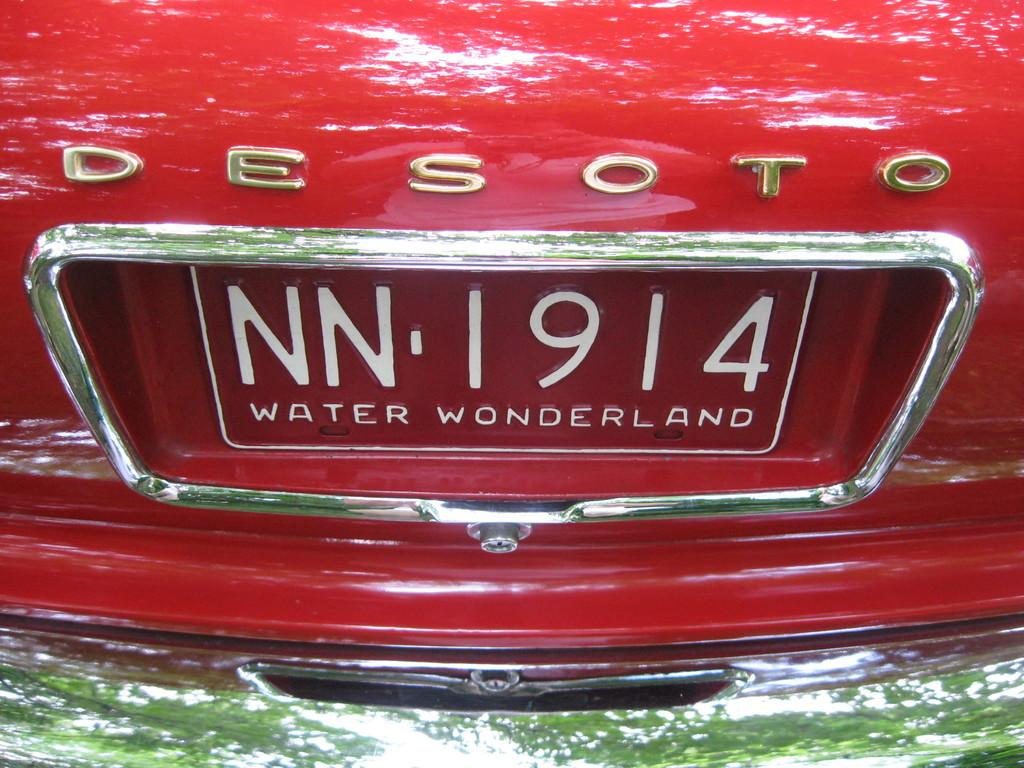What can be seen on the car in the image? There is a car number plate in the image. What else is present in the image besides the car number plate? There is a logo in the image. How many kittens can be seen playing with the pot in the image? There are no kittens or pots present in the image. What is the taste of the logo in the image? The logo is not something that can be tasted, as it is a visual element. 